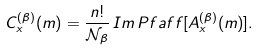Convert formula to latex. <formula><loc_0><loc_0><loc_500><loc_500>C ^ { ( \beta ) } _ { x } ( m ) = \frac { n ! } { \mathcal { N } _ { \beta } } \, I m \, P f a f f [ A ^ { ( \beta ) } _ { x } ( m ) ] .</formula> 